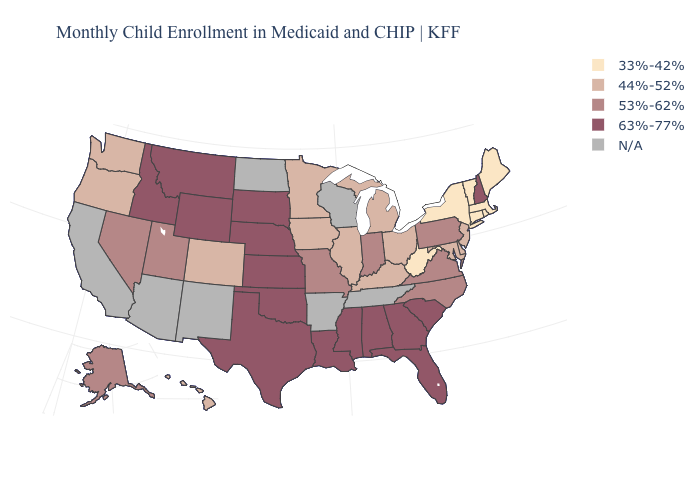Does the first symbol in the legend represent the smallest category?
Be succinct. Yes. What is the value of Pennsylvania?
Be succinct. 53%-62%. Name the states that have a value in the range 53%-62%?
Quick response, please. Alaska, Indiana, Missouri, Nevada, North Carolina, Pennsylvania, Utah, Virginia. Name the states that have a value in the range 44%-52%?
Keep it brief. Colorado, Delaware, Hawaii, Illinois, Iowa, Kentucky, Maryland, Michigan, Minnesota, New Jersey, Ohio, Oregon, Washington. Name the states that have a value in the range 33%-42%?
Quick response, please. Connecticut, Maine, Massachusetts, New York, Rhode Island, Vermont, West Virginia. What is the highest value in states that border Maryland?
Be succinct. 53%-62%. Name the states that have a value in the range 53%-62%?
Quick response, please. Alaska, Indiana, Missouri, Nevada, North Carolina, Pennsylvania, Utah, Virginia. Which states have the lowest value in the South?
Answer briefly. West Virginia. Which states have the highest value in the USA?
Keep it brief. Alabama, Florida, Georgia, Idaho, Kansas, Louisiana, Mississippi, Montana, Nebraska, New Hampshire, Oklahoma, South Carolina, South Dakota, Texas, Wyoming. Does Utah have the highest value in the USA?
Be succinct. No. What is the highest value in the MidWest ?
Write a very short answer. 63%-77%. 